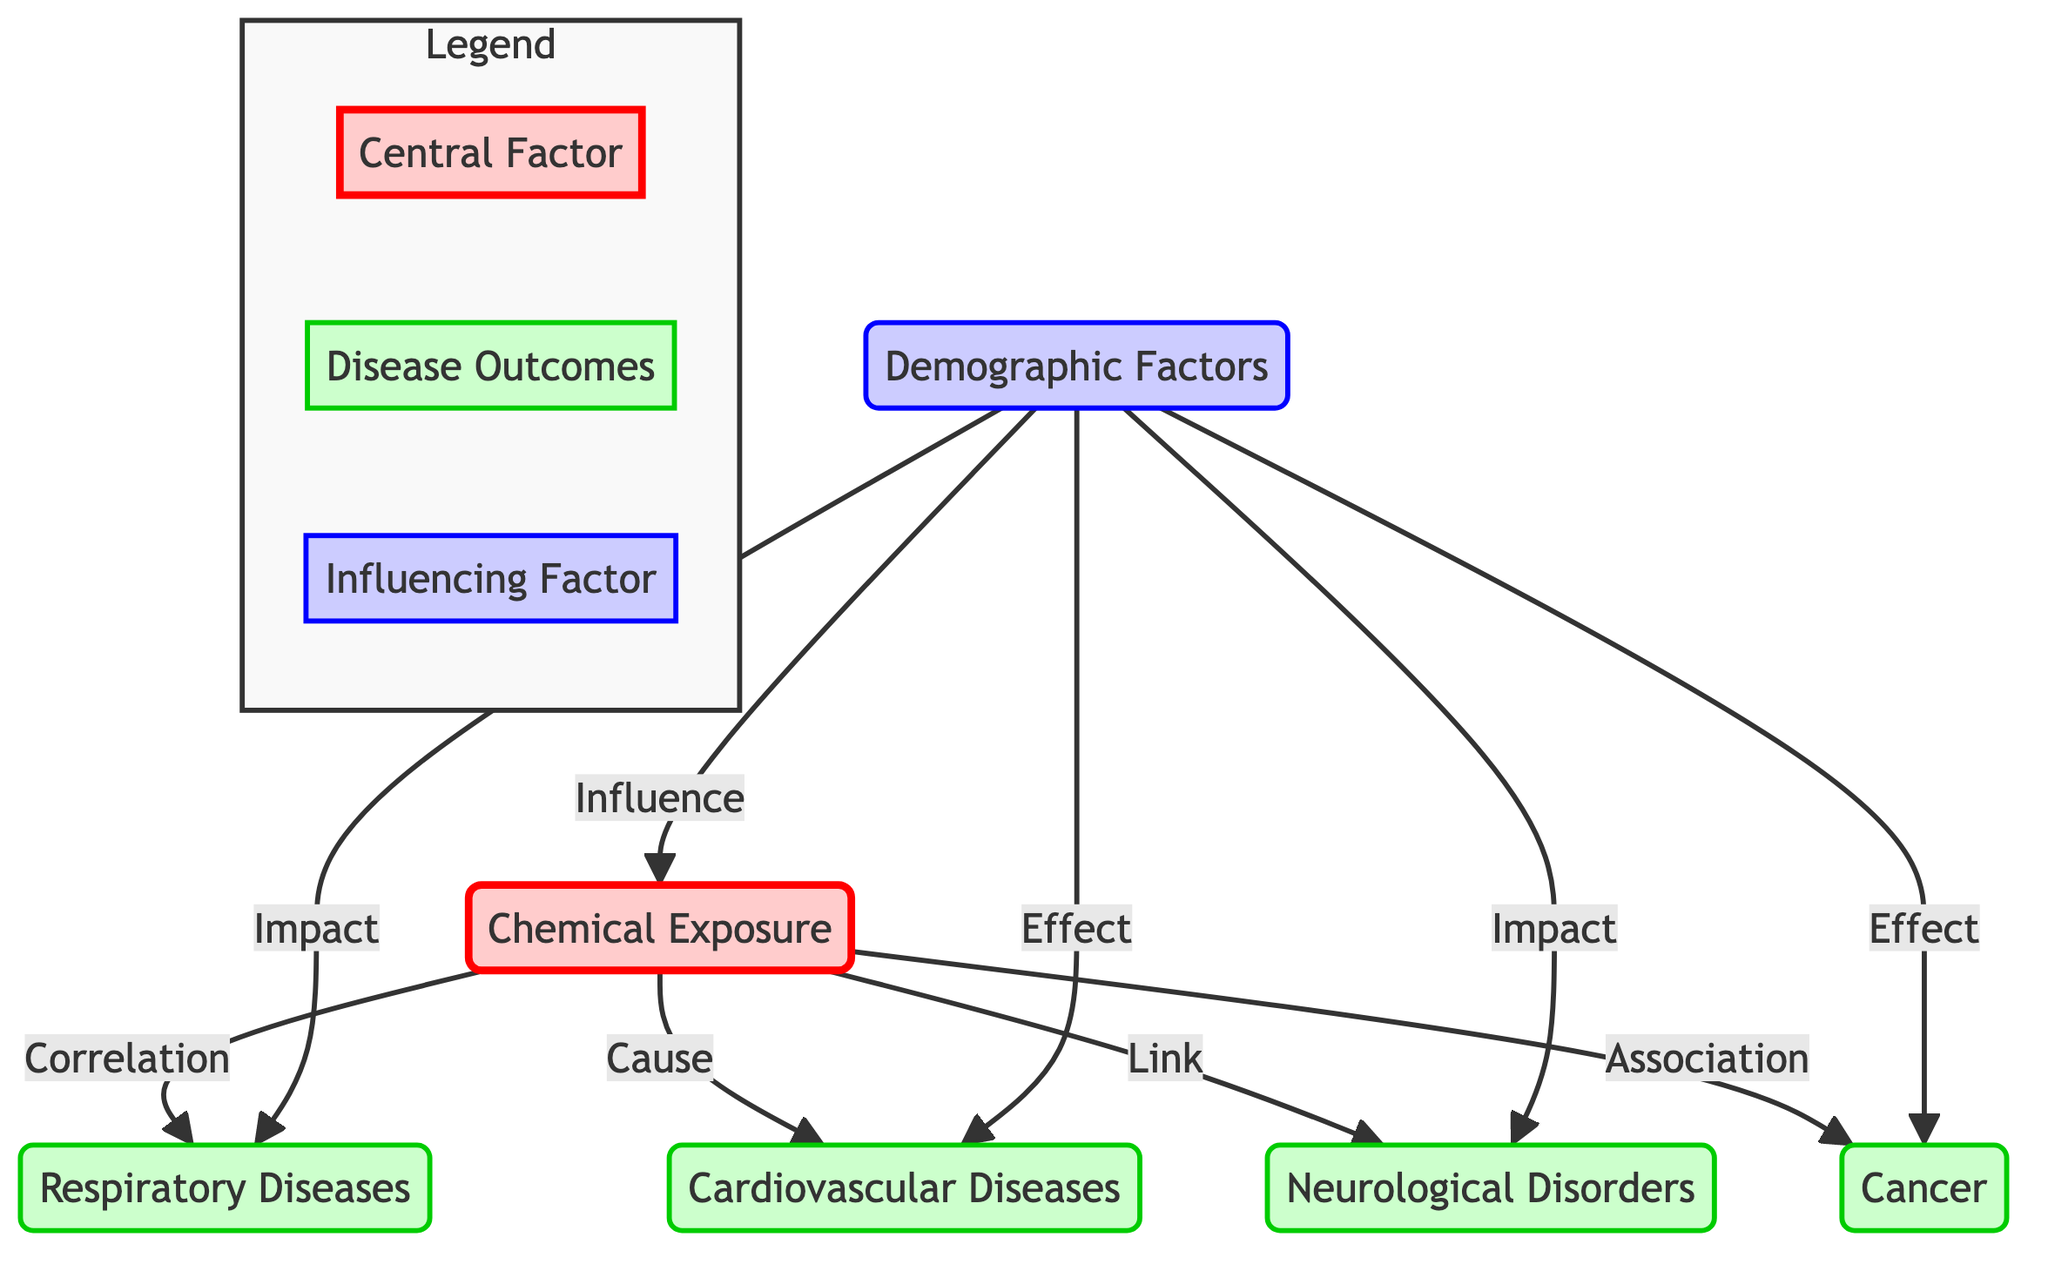What are the four disease outcomes linked to chemical exposure? The diagram lists four disease outcomes directly correlated with chemical exposure. These outcomes are respiratory diseases, cardiovascular diseases, neurological disorders, and cancer.
Answer: respiratory diseases, cardiovascular diseases, neurological disorders, cancer Which demographic factor influences chemical exposure? The diagram shows a unidirectional arrow from demographics pointing towards chemical exposure, indicating that demographic factors influence how chemical exposure occurs.
Answer: demographics How many total edges are there in the diagram? The diagram has a total of six edges: four connecting chemical exposure to disease outcomes and two connecting demographics to chemical exposure and disease outcomes.
Answer: six What type of relationship exists between chemical exposure and cardiovascular diseases? The diagram explicitly indicates a "Cause" relationship between chemical exposure and cardiovascular diseases, showing a direct causal link.
Answer: Cause How many disease outcomes are influenced by demographic factors? In the diagram, demographic factors impact all four disease outcomes listed: respiratory diseases, cardiovascular diseases, neurological disorders, and cancer, indicating a total of four influenced outcomes.
Answer: four Which disease is associated with chemical exposure according to the diagram? The diagram captures a direct association between chemical exposure and cancer, denoting a significant linkage.
Answer: cancer Which node has the classification 'Influencing Factor'? In the diagram, the demographics node is classified under the 'Influencing Factor' category, showing its role in influencing chemical exposure and disease outcomes.
Answer: demographics What is depicted in the central factor node of the diagram? The central factor node labeled as "Chemical Exposure" represents the primary focus of the diagram, illustrating its connection to various chronic diseases.
Answer: Chemical Exposure How do demographics impact neurological disorders? The diagram clearly shows that demographics influence neurological disorders through a direct impact relationship illustrated in the flow of the diagram.
Answer: Impact 